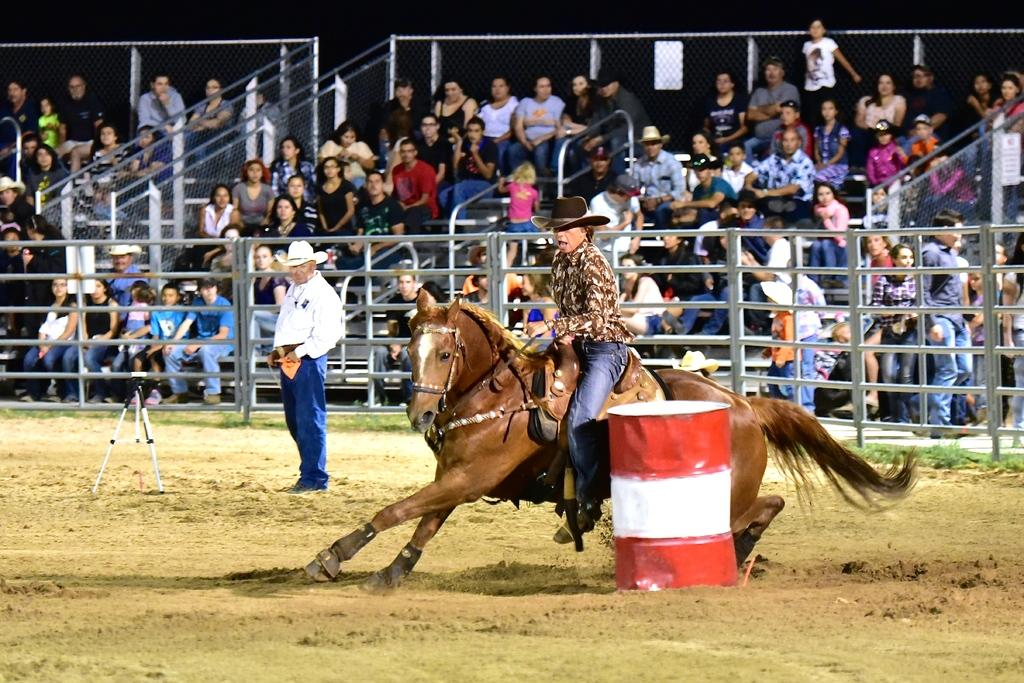What is the man in the image doing? The man is sitting on a horse in the image. What other objects or items can be seen in the image? There is a barrel, people sitting on chairs, and a stand in the image. What is the man near the stand doing? There is a man standing near the stand in the image. What type of stick is the man using to break out of prison in the image? There is no prison or stick present in the image. 